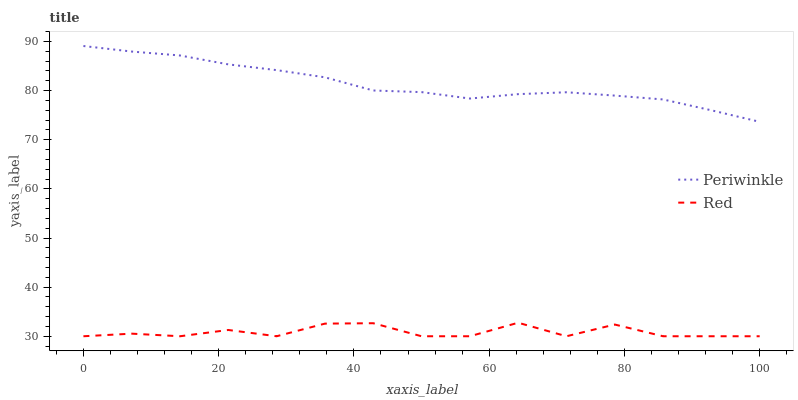Does Red have the minimum area under the curve?
Answer yes or no. Yes. Does Periwinkle have the maximum area under the curve?
Answer yes or no. Yes. Does Red have the maximum area under the curve?
Answer yes or no. No. Is Periwinkle the smoothest?
Answer yes or no. Yes. Is Red the roughest?
Answer yes or no. Yes. Is Red the smoothest?
Answer yes or no. No. Does Periwinkle have the highest value?
Answer yes or no. Yes. Does Red have the highest value?
Answer yes or no. No. Is Red less than Periwinkle?
Answer yes or no. Yes. Is Periwinkle greater than Red?
Answer yes or no. Yes. Does Red intersect Periwinkle?
Answer yes or no. No. 